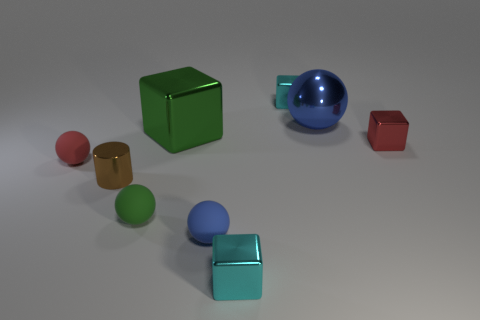There is a thing that is the same color as the large shiny sphere; what material is it?
Provide a succinct answer. Rubber. What number of other objects are there of the same size as the red matte sphere?
Give a very brief answer. 6. What number of things are either small cyan metallic things behind the large green metallic block or blue things?
Your answer should be very brief. 3. What color is the large cube?
Keep it short and to the point. Green. There is a cyan thing that is behind the big green metal thing; what material is it?
Offer a very short reply. Metal. Is the shape of the large green thing the same as the tiny red object to the left of the red metallic block?
Your response must be concise. No. Is the number of green rubber spheres greater than the number of spheres?
Offer a very short reply. No. Are there any other things that have the same color as the tiny cylinder?
Offer a very short reply. No. There is a red thing that is the same material as the cylinder; what shape is it?
Offer a very short reply. Cube. What material is the blue sphere behind the small metallic object on the left side of the green cube?
Offer a terse response. Metal. 